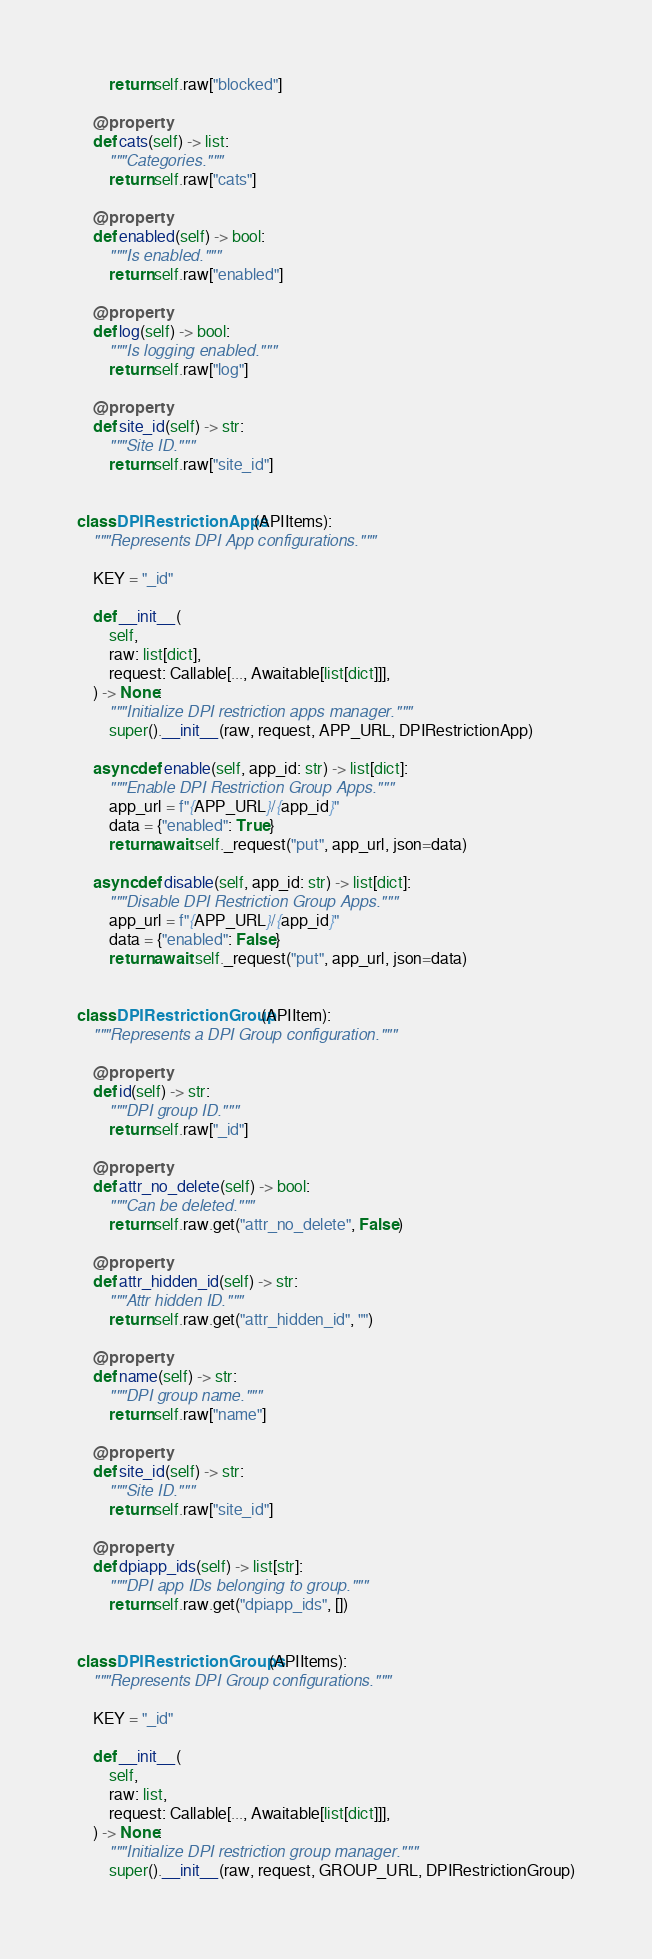Convert code to text. <code><loc_0><loc_0><loc_500><loc_500><_Python_>        return self.raw["blocked"]

    @property
    def cats(self) -> list:
        """Categories."""
        return self.raw["cats"]

    @property
    def enabled(self) -> bool:
        """Is enabled."""
        return self.raw["enabled"]

    @property
    def log(self) -> bool:
        """Is logging enabled."""
        return self.raw["log"]

    @property
    def site_id(self) -> str:
        """Site ID."""
        return self.raw["site_id"]


class DPIRestrictionApps(APIItems):
    """Represents DPI App configurations."""

    KEY = "_id"

    def __init__(
        self,
        raw: list[dict],
        request: Callable[..., Awaitable[list[dict]]],
    ) -> None:
        """Initialize DPI restriction apps manager."""
        super().__init__(raw, request, APP_URL, DPIRestrictionApp)

    async def enable(self, app_id: str) -> list[dict]:
        """Enable DPI Restriction Group Apps."""
        app_url = f"{APP_URL}/{app_id}"
        data = {"enabled": True}
        return await self._request("put", app_url, json=data)

    async def disable(self, app_id: str) -> list[dict]:
        """Disable DPI Restriction Group Apps."""
        app_url = f"{APP_URL}/{app_id}"
        data = {"enabled": False}
        return await self._request("put", app_url, json=data)


class DPIRestrictionGroup(APIItem):
    """Represents a DPI Group configuration."""

    @property
    def id(self) -> str:
        """DPI group ID."""
        return self.raw["_id"]

    @property
    def attr_no_delete(self) -> bool:
        """Can be deleted."""
        return self.raw.get("attr_no_delete", False)

    @property
    def attr_hidden_id(self) -> str:
        """Attr hidden ID."""
        return self.raw.get("attr_hidden_id", "")

    @property
    def name(self) -> str:
        """DPI group name."""
        return self.raw["name"]

    @property
    def site_id(self) -> str:
        """Site ID."""
        return self.raw["site_id"]

    @property
    def dpiapp_ids(self) -> list[str]:
        """DPI app IDs belonging to group."""
        return self.raw.get("dpiapp_ids", [])


class DPIRestrictionGroups(APIItems):
    """Represents DPI Group configurations."""

    KEY = "_id"

    def __init__(
        self,
        raw: list,
        request: Callable[..., Awaitable[list[dict]]],
    ) -> None:
        """Initialize DPI restriction group manager."""
        super().__init__(raw, request, GROUP_URL, DPIRestrictionGroup)
</code> 